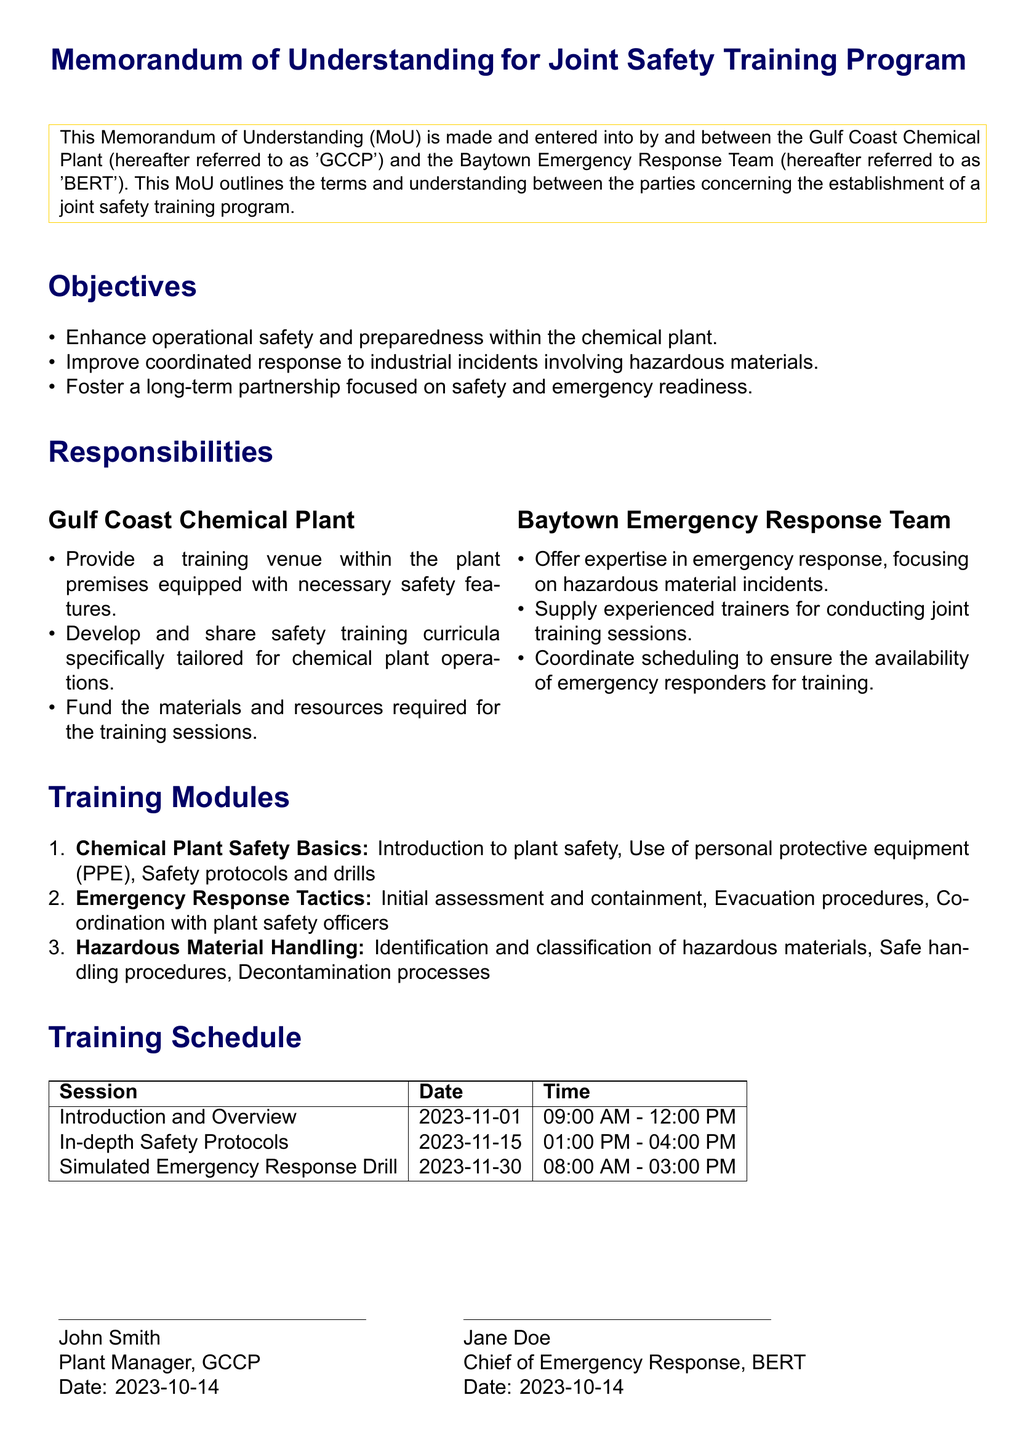What is the title of the document? The title is presented prominently at the beginning of the document, stating the purpose of the MoU.
Answer: Memorandum of Understanding for Joint Safety Training Program Who are the parties involved in the MoU? The parties involved are clearly defined in the introductory section of the document.
Answer: Gulf Coast Chemical Plant and Baytown Emergency Response Team What is the date of the first training session? The date for the first session can be retrieved from the training schedule table in the document.
Answer: 2023-11-01 How many training modules are listed in the document? The total count of training modules can be found in the section detailing the training modules.
Answer: 3 What is one responsibility of the Gulf Coast Chemical Plant? One responsibility is mentioned under the responsibilities section specifically for GCCP.
Answer: Provide a training venue within the plant premises equipped with necessary safety features What is the time for the Simulated Emergency Response Drill? The time is available in the training schedule for the specified session.
Answer: 08:00 AM - 03:00 PM What is the purpose of the joint safety training program? The objectives listed at the beginning outline the purpose of the program.
Answer: Enhance operational safety and preparedness within the chemical plant Who signed the document on behalf of BERT? The signatory for BERT is clearly stated at the end of the document.
Answer: Jane Doe 